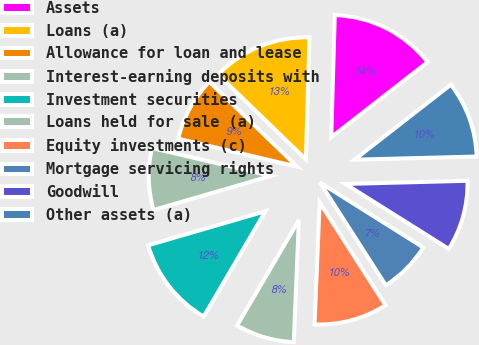<chart> <loc_0><loc_0><loc_500><loc_500><pie_chart><fcel>Assets<fcel>Loans (a)<fcel>Allowance for loan and lease<fcel>Interest-earning deposits with<fcel>Investment securities<fcel>Loans held for sale (a)<fcel>Equity investments (c)<fcel>Mortgage servicing rights<fcel>Goodwill<fcel>Other assets (a)<nl><fcel>14.01%<fcel>13.23%<fcel>8.56%<fcel>8.17%<fcel>12.06%<fcel>7.78%<fcel>9.73%<fcel>7.0%<fcel>9.34%<fcel>10.12%<nl></chart> 